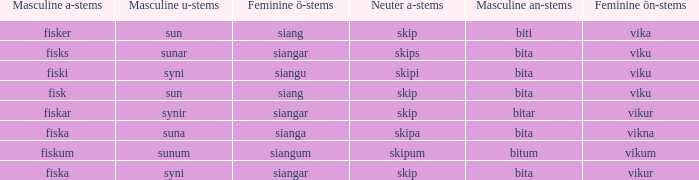What is the masculine an form for the word with a feminine ö ending of siangar and a masculine u ending of sunar? Bita. 